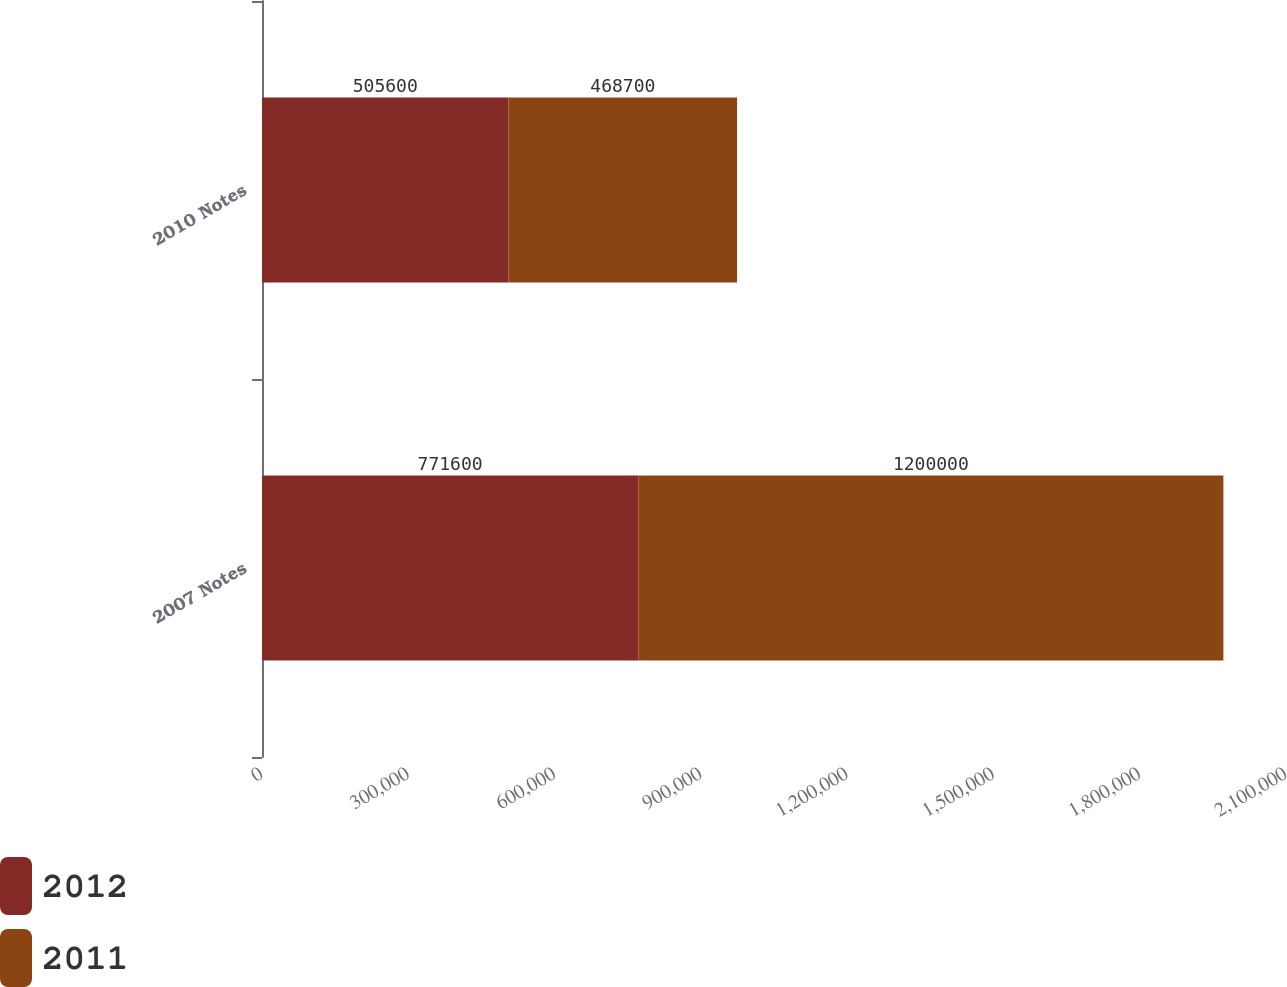Convert chart to OTSL. <chart><loc_0><loc_0><loc_500><loc_500><stacked_bar_chart><ecel><fcel>2007 Notes<fcel>2010 Notes<nl><fcel>2012<fcel>771600<fcel>505600<nl><fcel>2011<fcel>1.2e+06<fcel>468700<nl></chart> 